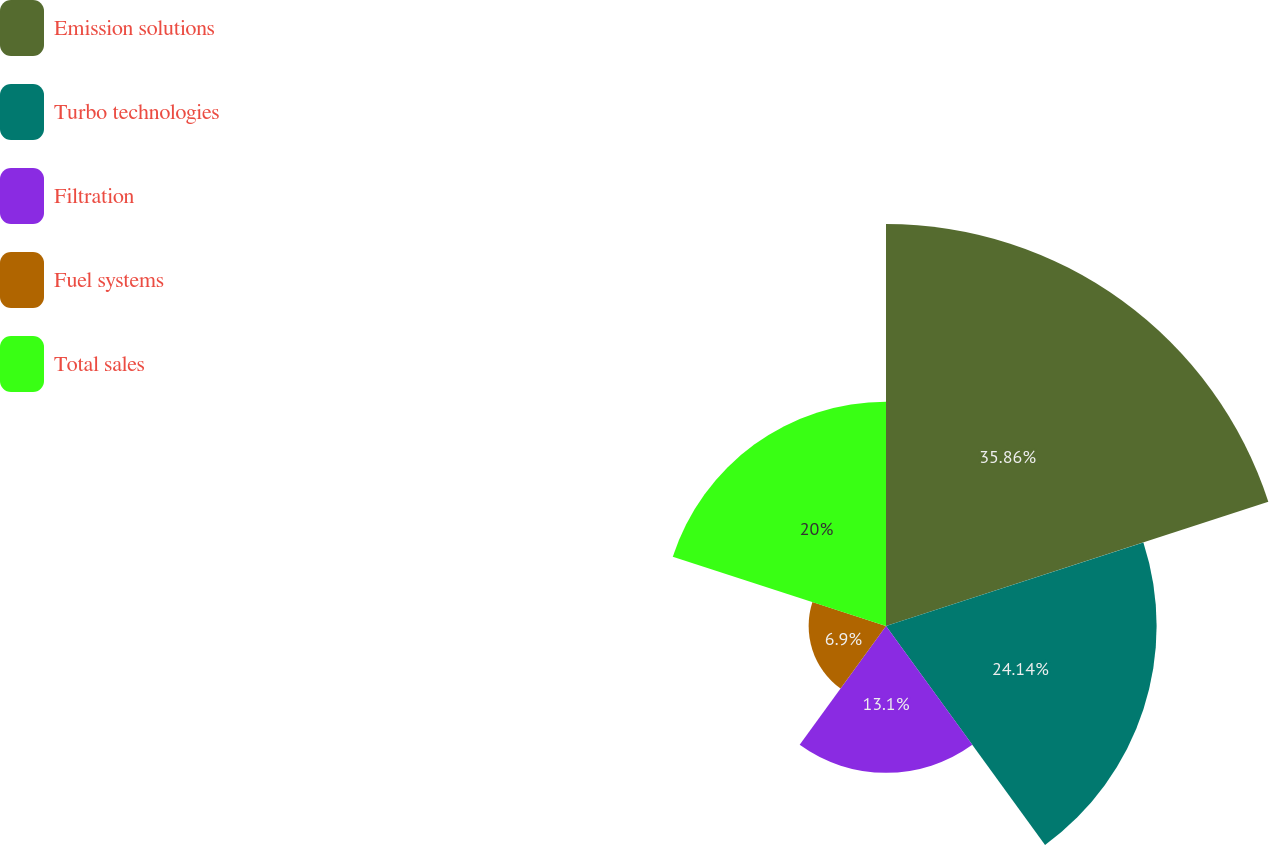Convert chart to OTSL. <chart><loc_0><loc_0><loc_500><loc_500><pie_chart><fcel>Emission solutions<fcel>Turbo technologies<fcel>Filtration<fcel>Fuel systems<fcel>Total sales<nl><fcel>35.86%<fcel>24.14%<fcel>13.1%<fcel>6.9%<fcel>20.0%<nl></chart> 